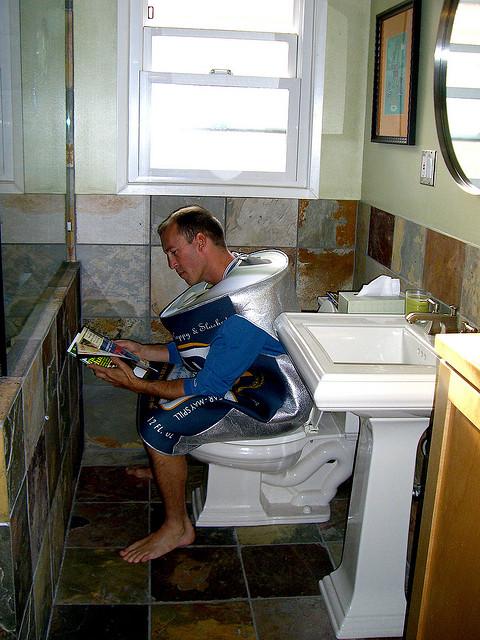What is the man dressed as?
Quick response, please. Can. What is the man sitting on?
Write a very short answer. Toilet. Is this a study room?
Short answer required. No. 